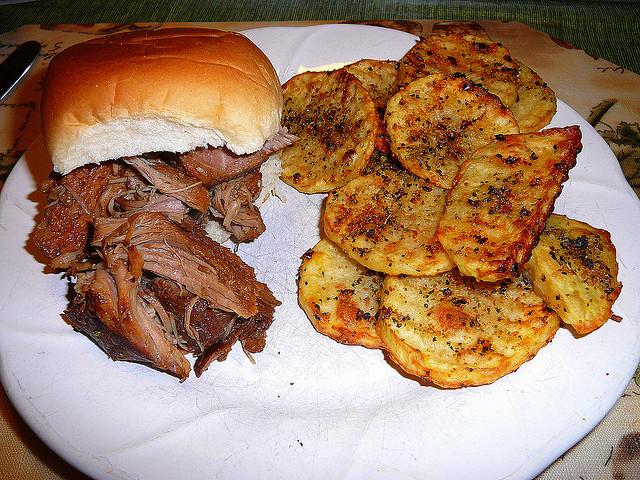The item on the right is most likely a cooked version of what?

Choices:
A) potato
B) carrot
C) orange
D) lemon potato 